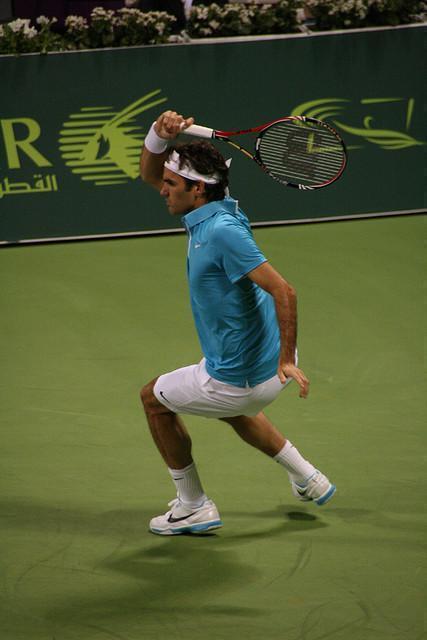What is the athletes last name?
Choose the correct response, then elucidate: 'Answer: answer
Rationale: rationale.'
Options: Garrett, jackson, federer, jones. Answer: federer.
Rationale: A man with dark hair is playing tennis. 